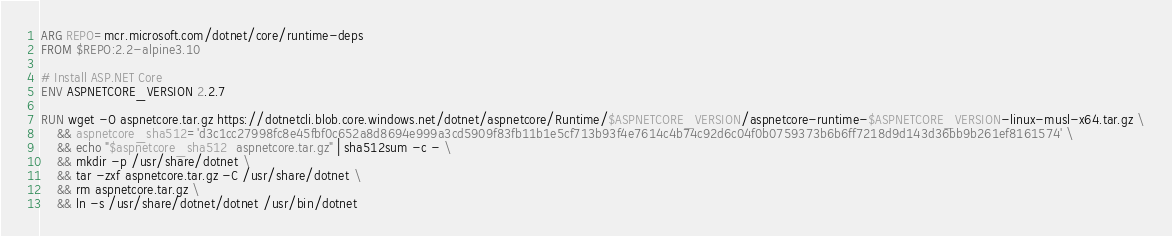Convert code to text. <code><loc_0><loc_0><loc_500><loc_500><_Dockerfile_>ARG REPO=mcr.microsoft.com/dotnet/core/runtime-deps
FROM $REPO:2.2-alpine3.10

# Install ASP.NET Core
ENV ASPNETCORE_VERSION 2.2.7

RUN wget -O aspnetcore.tar.gz https://dotnetcli.blob.core.windows.net/dotnet/aspnetcore/Runtime/$ASPNETCORE_VERSION/aspnetcore-runtime-$ASPNETCORE_VERSION-linux-musl-x64.tar.gz \
    && aspnetcore_sha512='d3c1cc27998fc8e45fbf0c652a8d8694e999a3cd5909f83fb11b1e5cf713b93f4e7614c4b74c92d6c04f0b0759373b6b6ff7218d9d143d36bb9b261ef8161574' \
    && echo "$aspnetcore_sha512  aspnetcore.tar.gz" | sha512sum -c - \
    && mkdir -p /usr/share/dotnet \
    && tar -zxf aspnetcore.tar.gz -C /usr/share/dotnet \
    && rm aspnetcore.tar.gz \
    && ln -s /usr/share/dotnet/dotnet /usr/bin/dotnet
</code> 